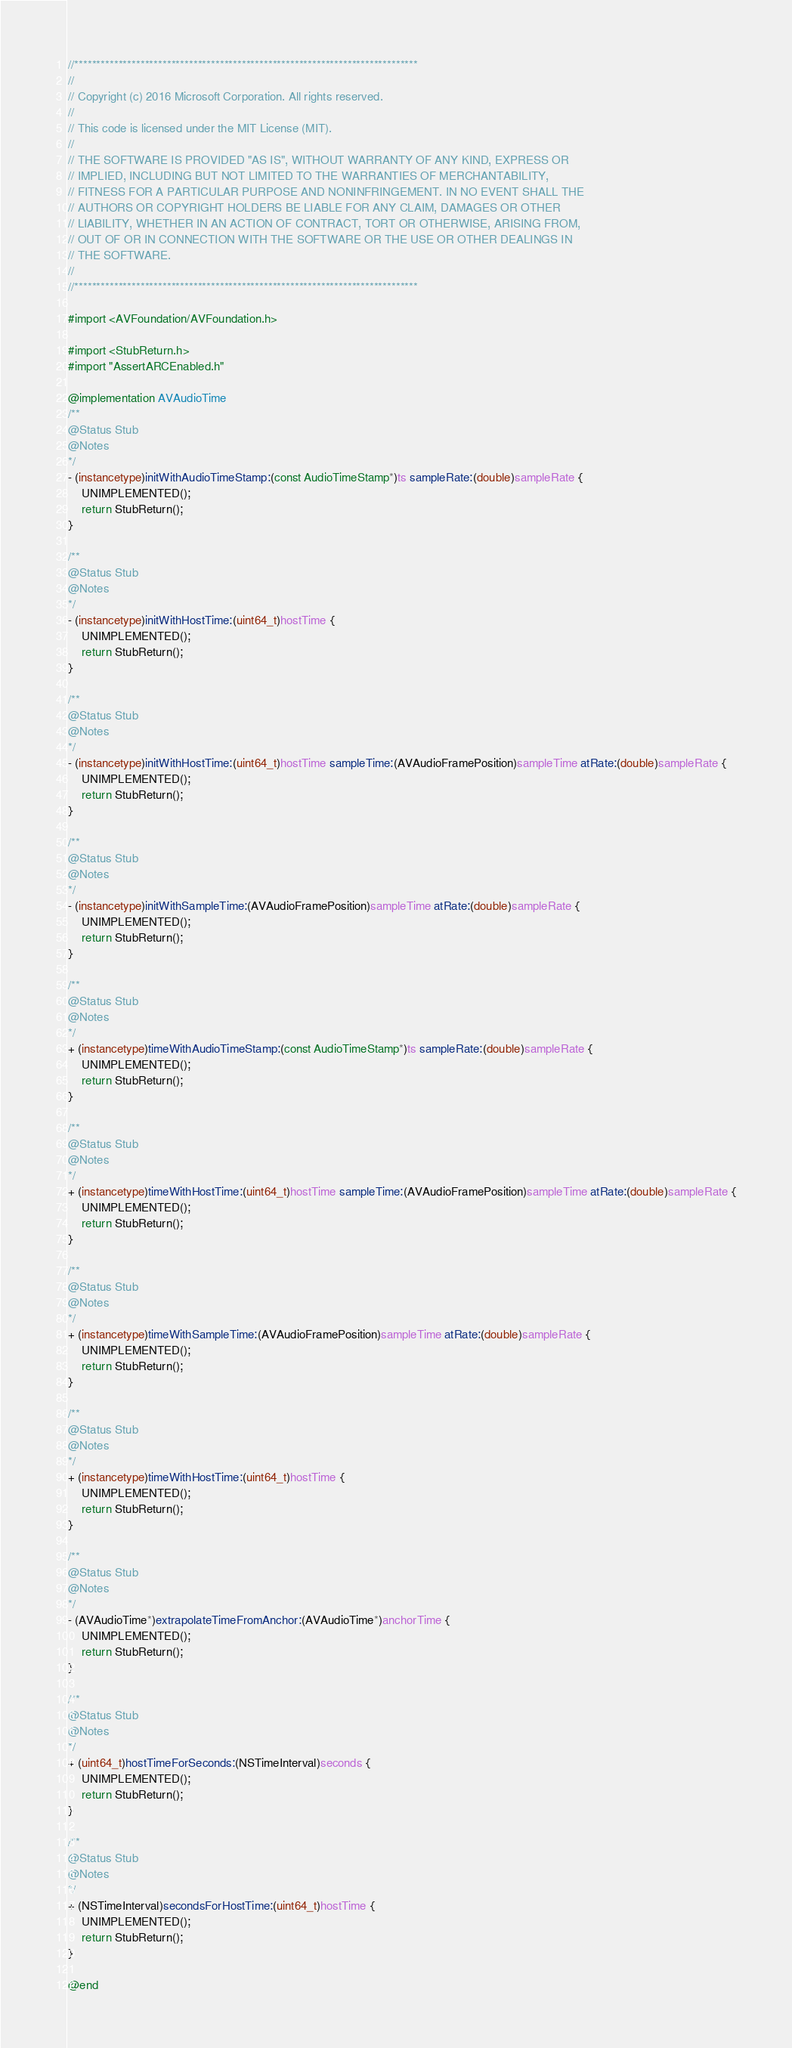<code> <loc_0><loc_0><loc_500><loc_500><_ObjectiveC_>//******************************************************************************
//
// Copyright (c) 2016 Microsoft Corporation. All rights reserved.
//
// This code is licensed under the MIT License (MIT).
//
// THE SOFTWARE IS PROVIDED "AS IS", WITHOUT WARRANTY OF ANY KIND, EXPRESS OR
// IMPLIED, INCLUDING BUT NOT LIMITED TO THE WARRANTIES OF MERCHANTABILITY,
// FITNESS FOR A PARTICULAR PURPOSE AND NONINFRINGEMENT. IN NO EVENT SHALL THE
// AUTHORS OR COPYRIGHT HOLDERS BE LIABLE FOR ANY CLAIM, DAMAGES OR OTHER
// LIABILITY, WHETHER IN AN ACTION OF CONTRACT, TORT OR OTHERWISE, ARISING FROM,
// OUT OF OR IN CONNECTION WITH THE SOFTWARE OR THE USE OR OTHER DEALINGS IN
// THE SOFTWARE.
//
//******************************************************************************

#import <AVFoundation/AVFoundation.h>

#import <StubReturn.h>
#import "AssertARCEnabled.h"

@implementation AVAudioTime
/**
@Status Stub
@Notes
*/
- (instancetype)initWithAudioTimeStamp:(const AudioTimeStamp*)ts sampleRate:(double)sampleRate {
    UNIMPLEMENTED();
    return StubReturn();
}

/**
@Status Stub
@Notes
*/
- (instancetype)initWithHostTime:(uint64_t)hostTime {
    UNIMPLEMENTED();
    return StubReturn();
}

/**
@Status Stub
@Notes
*/
- (instancetype)initWithHostTime:(uint64_t)hostTime sampleTime:(AVAudioFramePosition)sampleTime atRate:(double)sampleRate {
    UNIMPLEMENTED();
    return StubReturn();
}

/**
@Status Stub
@Notes
*/
- (instancetype)initWithSampleTime:(AVAudioFramePosition)sampleTime atRate:(double)sampleRate {
    UNIMPLEMENTED();
    return StubReturn();
}

/**
@Status Stub
@Notes
*/
+ (instancetype)timeWithAudioTimeStamp:(const AudioTimeStamp*)ts sampleRate:(double)sampleRate {
    UNIMPLEMENTED();
    return StubReturn();
}

/**
@Status Stub
@Notes
*/
+ (instancetype)timeWithHostTime:(uint64_t)hostTime sampleTime:(AVAudioFramePosition)sampleTime atRate:(double)sampleRate {
    UNIMPLEMENTED();
    return StubReturn();
}

/**
@Status Stub
@Notes
*/
+ (instancetype)timeWithSampleTime:(AVAudioFramePosition)sampleTime atRate:(double)sampleRate {
    UNIMPLEMENTED();
    return StubReturn();
}

/**
@Status Stub
@Notes
*/
+ (instancetype)timeWithHostTime:(uint64_t)hostTime {
    UNIMPLEMENTED();
    return StubReturn();
}

/**
@Status Stub
@Notes
*/
- (AVAudioTime*)extrapolateTimeFromAnchor:(AVAudioTime*)anchorTime {
    UNIMPLEMENTED();
    return StubReturn();
}

/**
@Status Stub
@Notes
*/
+ (uint64_t)hostTimeForSeconds:(NSTimeInterval)seconds {
    UNIMPLEMENTED();
    return StubReturn();
}

/**
@Status Stub
@Notes
*/
+ (NSTimeInterval)secondsForHostTime:(uint64_t)hostTime {
    UNIMPLEMENTED();
    return StubReturn();
}

@end
</code> 